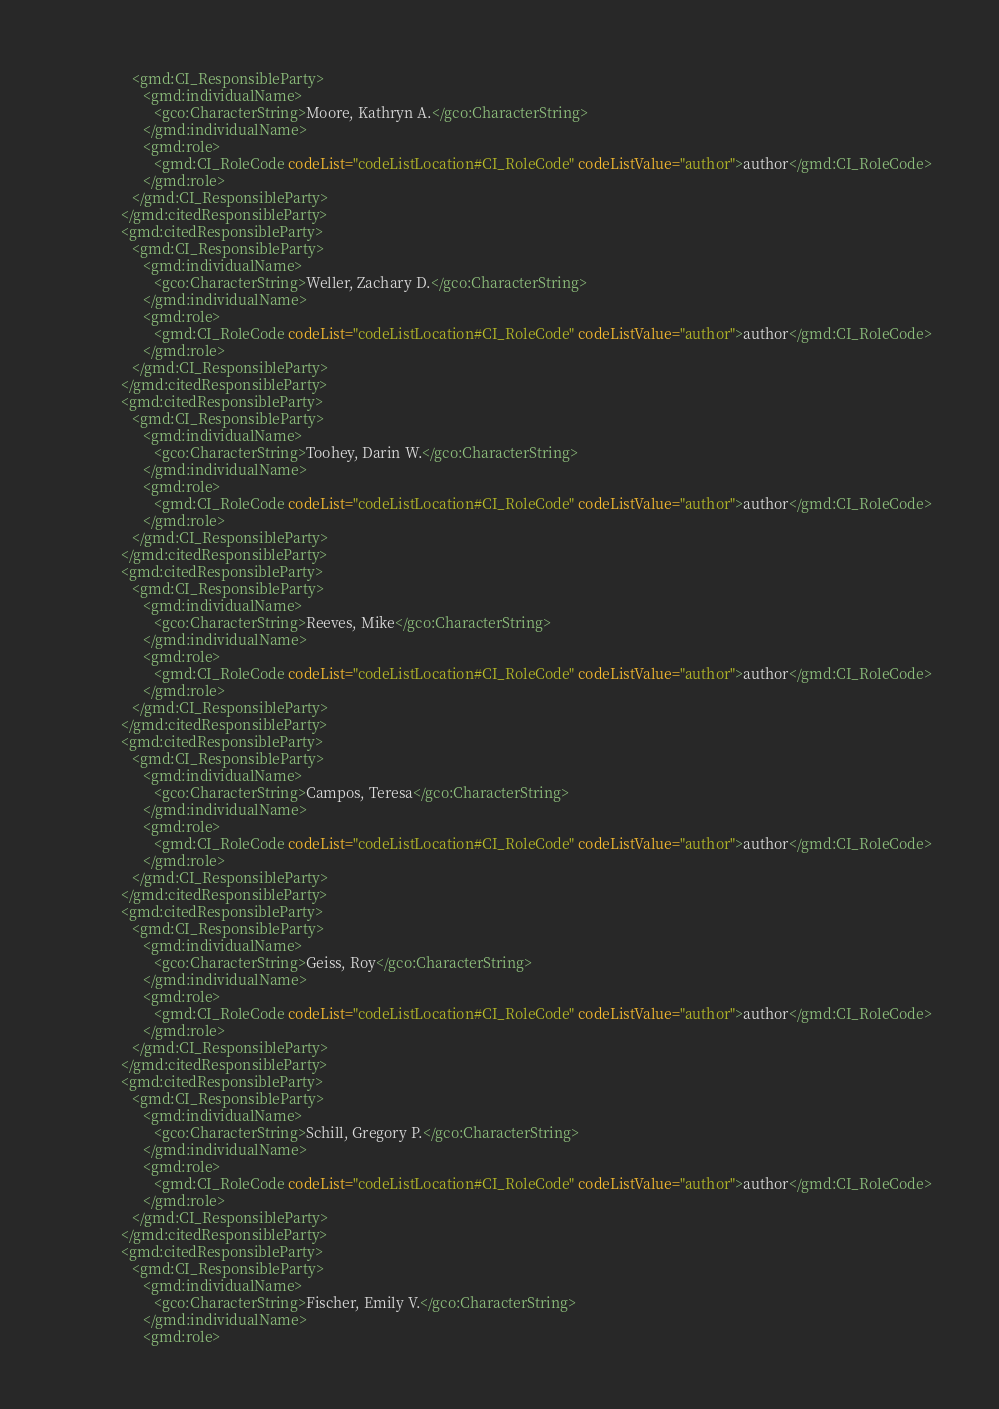<code> <loc_0><loc_0><loc_500><loc_500><_XML_>                  <gmd:CI_ResponsibleParty>
                     <gmd:individualName>
                        <gco:CharacterString>Moore, Kathryn A.</gco:CharacterString>
                     </gmd:individualName>
                     <gmd:role>
                        <gmd:CI_RoleCode codeList="codeListLocation#CI_RoleCode" codeListValue="author">author</gmd:CI_RoleCode>
                     </gmd:role>
                  </gmd:CI_ResponsibleParty>
               </gmd:citedResponsibleParty>
               <gmd:citedResponsibleParty>
                  <gmd:CI_ResponsibleParty>
                     <gmd:individualName>
                        <gco:CharacterString>Weller, Zachary D.</gco:CharacterString>
                     </gmd:individualName>
                     <gmd:role>
                        <gmd:CI_RoleCode codeList="codeListLocation#CI_RoleCode" codeListValue="author">author</gmd:CI_RoleCode>
                     </gmd:role>
                  </gmd:CI_ResponsibleParty>
               </gmd:citedResponsibleParty>
               <gmd:citedResponsibleParty>
                  <gmd:CI_ResponsibleParty>
                     <gmd:individualName>
                        <gco:CharacterString>Toohey, Darin W.</gco:CharacterString>
                     </gmd:individualName>
                     <gmd:role>
                        <gmd:CI_RoleCode codeList="codeListLocation#CI_RoleCode" codeListValue="author">author</gmd:CI_RoleCode>
                     </gmd:role>
                  </gmd:CI_ResponsibleParty>
               </gmd:citedResponsibleParty>
               <gmd:citedResponsibleParty>
                  <gmd:CI_ResponsibleParty>
                     <gmd:individualName>
                        <gco:CharacterString>Reeves, Mike</gco:CharacterString>
                     </gmd:individualName>
                     <gmd:role>
                        <gmd:CI_RoleCode codeList="codeListLocation#CI_RoleCode" codeListValue="author">author</gmd:CI_RoleCode>
                     </gmd:role>
                  </gmd:CI_ResponsibleParty>
               </gmd:citedResponsibleParty>
               <gmd:citedResponsibleParty>
                  <gmd:CI_ResponsibleParty>
                     <gmd:individualName>
                        <gco:CharacterString>Campos, Teresa</gco:CharacterString>
                     </gmd:individualName>
                     <gmd:role>
                        <gmd:CI_RoleCode codeList="codeListLocation#CI_RoleCode" codeListValue="author">author</gmd:CI_RoleCode>
                     </gmd:role>
                  </gmd:CI_ResponsibleParty>
               </gmd:citedResponsibleParty>
               <gmd:citedResponsibleParty>
                  <gmd:CI_ResponsibleParty>
                     <gmd:individualName>
                        <gco:CharacterString>Geiss, Roy</gco:CharacterString>
                     </gmd:individualName>
                     <gmd:role>
                        <gmd:CI_RoleCode codeList="codeListLocation#CI_RoleCode" codeListValue="author">author</gmd:CI_RoleCode>
                     </gmd:role>
                  </gmd:CI_ResponsibleParty>
               </gmd:citedResponsibleParty>
               <gmd:citedResponsibleParty>
                  <gmd:CI_ResponsibleParty>
                     <gmd:individualName>
                        <gco:CharacterString>Schill, Gregory P.</gco:CharacterString>
                     </gmd:individualName>
                     <gmd:role>
                        <gmd:CI_RoleCode codeList="codeListLocation#CI_RoleCode" codeListValue="author">author</gmd:CI_RoleCode>
                     </gmd:role>
                  </gmd:CI_ResponsibleParty>
               </gmd:citedResponsibleParty>
               <gmd:citedResponsibleParty>
                  <gmd:CI_ResponsibleParty>
                     <gmd:individualName>
                        <gco:CharacterString>Fischer, Emily V.</gco:CharacterString>
                     </gmd:individualName>
                     <gmd:role></code> 